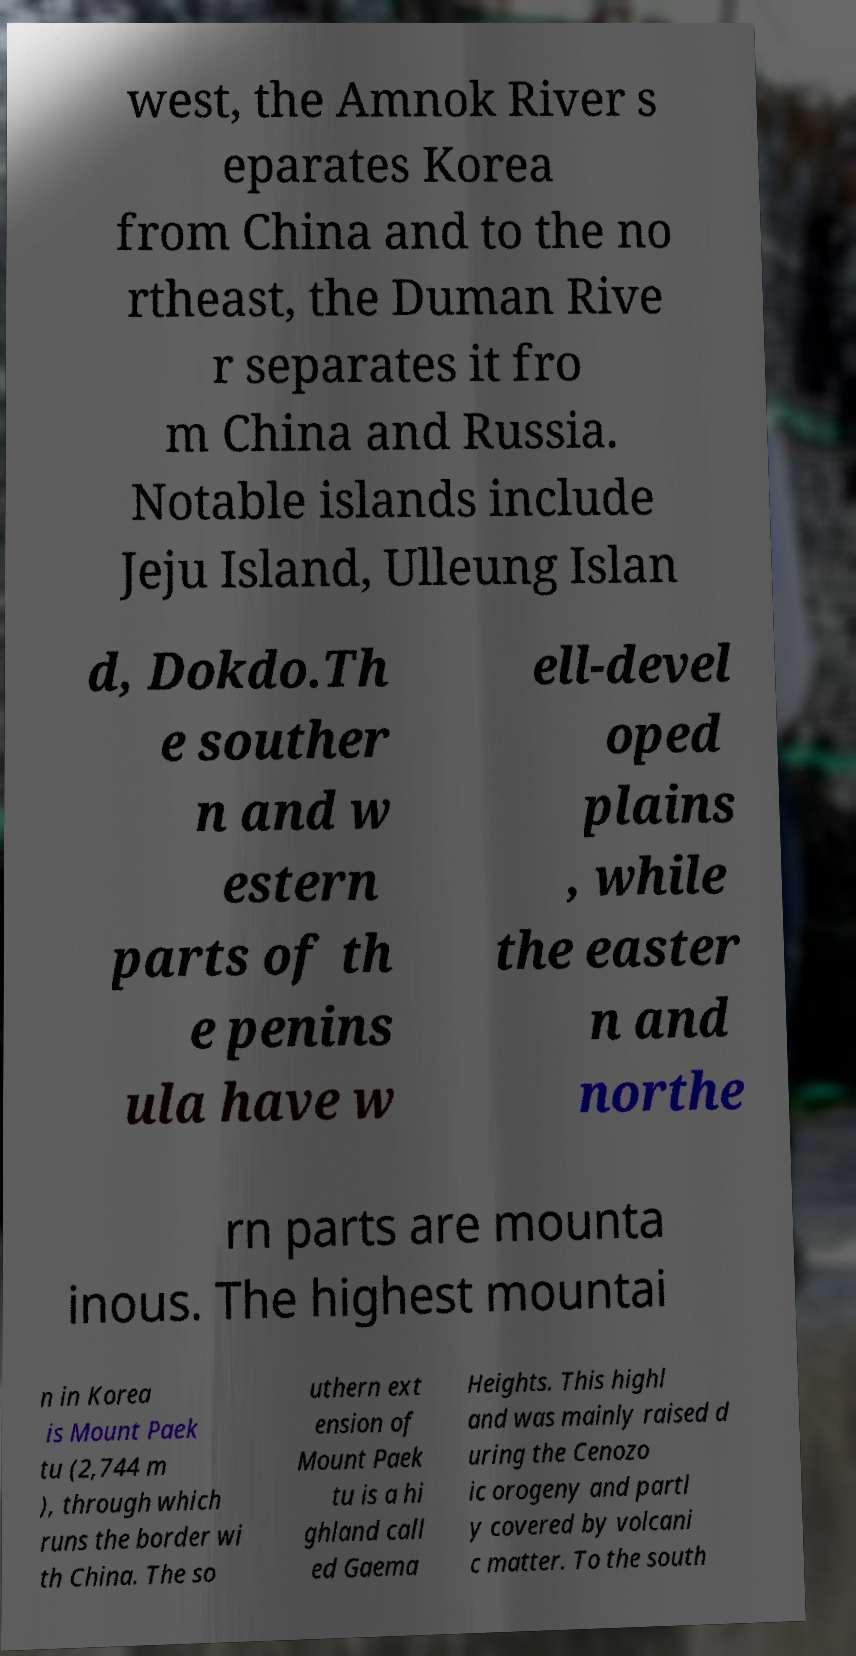I need the written content from this picture converted into text. Can you do that? west, the Amnok River s eparates Korea from China and to the no rtheast, the Duman Rive r separates it fro m China and Russia. Notable islands include Jeju Island, Ulleung Islan d, Dokdo.Th e souther n and w estern parts of th e penins ula have w ell-devel oped plains , while the easter n and northe rn parts are mounta inous. The highest mountai n in Korea is Mount Paek tu (2,744 m ), through which runs the border wi th China. The so uthern ext ension of Mount Paek tu is a hi ghland call ed Gaema Heights. This highl and was mainly raised d uring the Cenozo ic orogeny and partl y covered by volcani c matter. To the south 